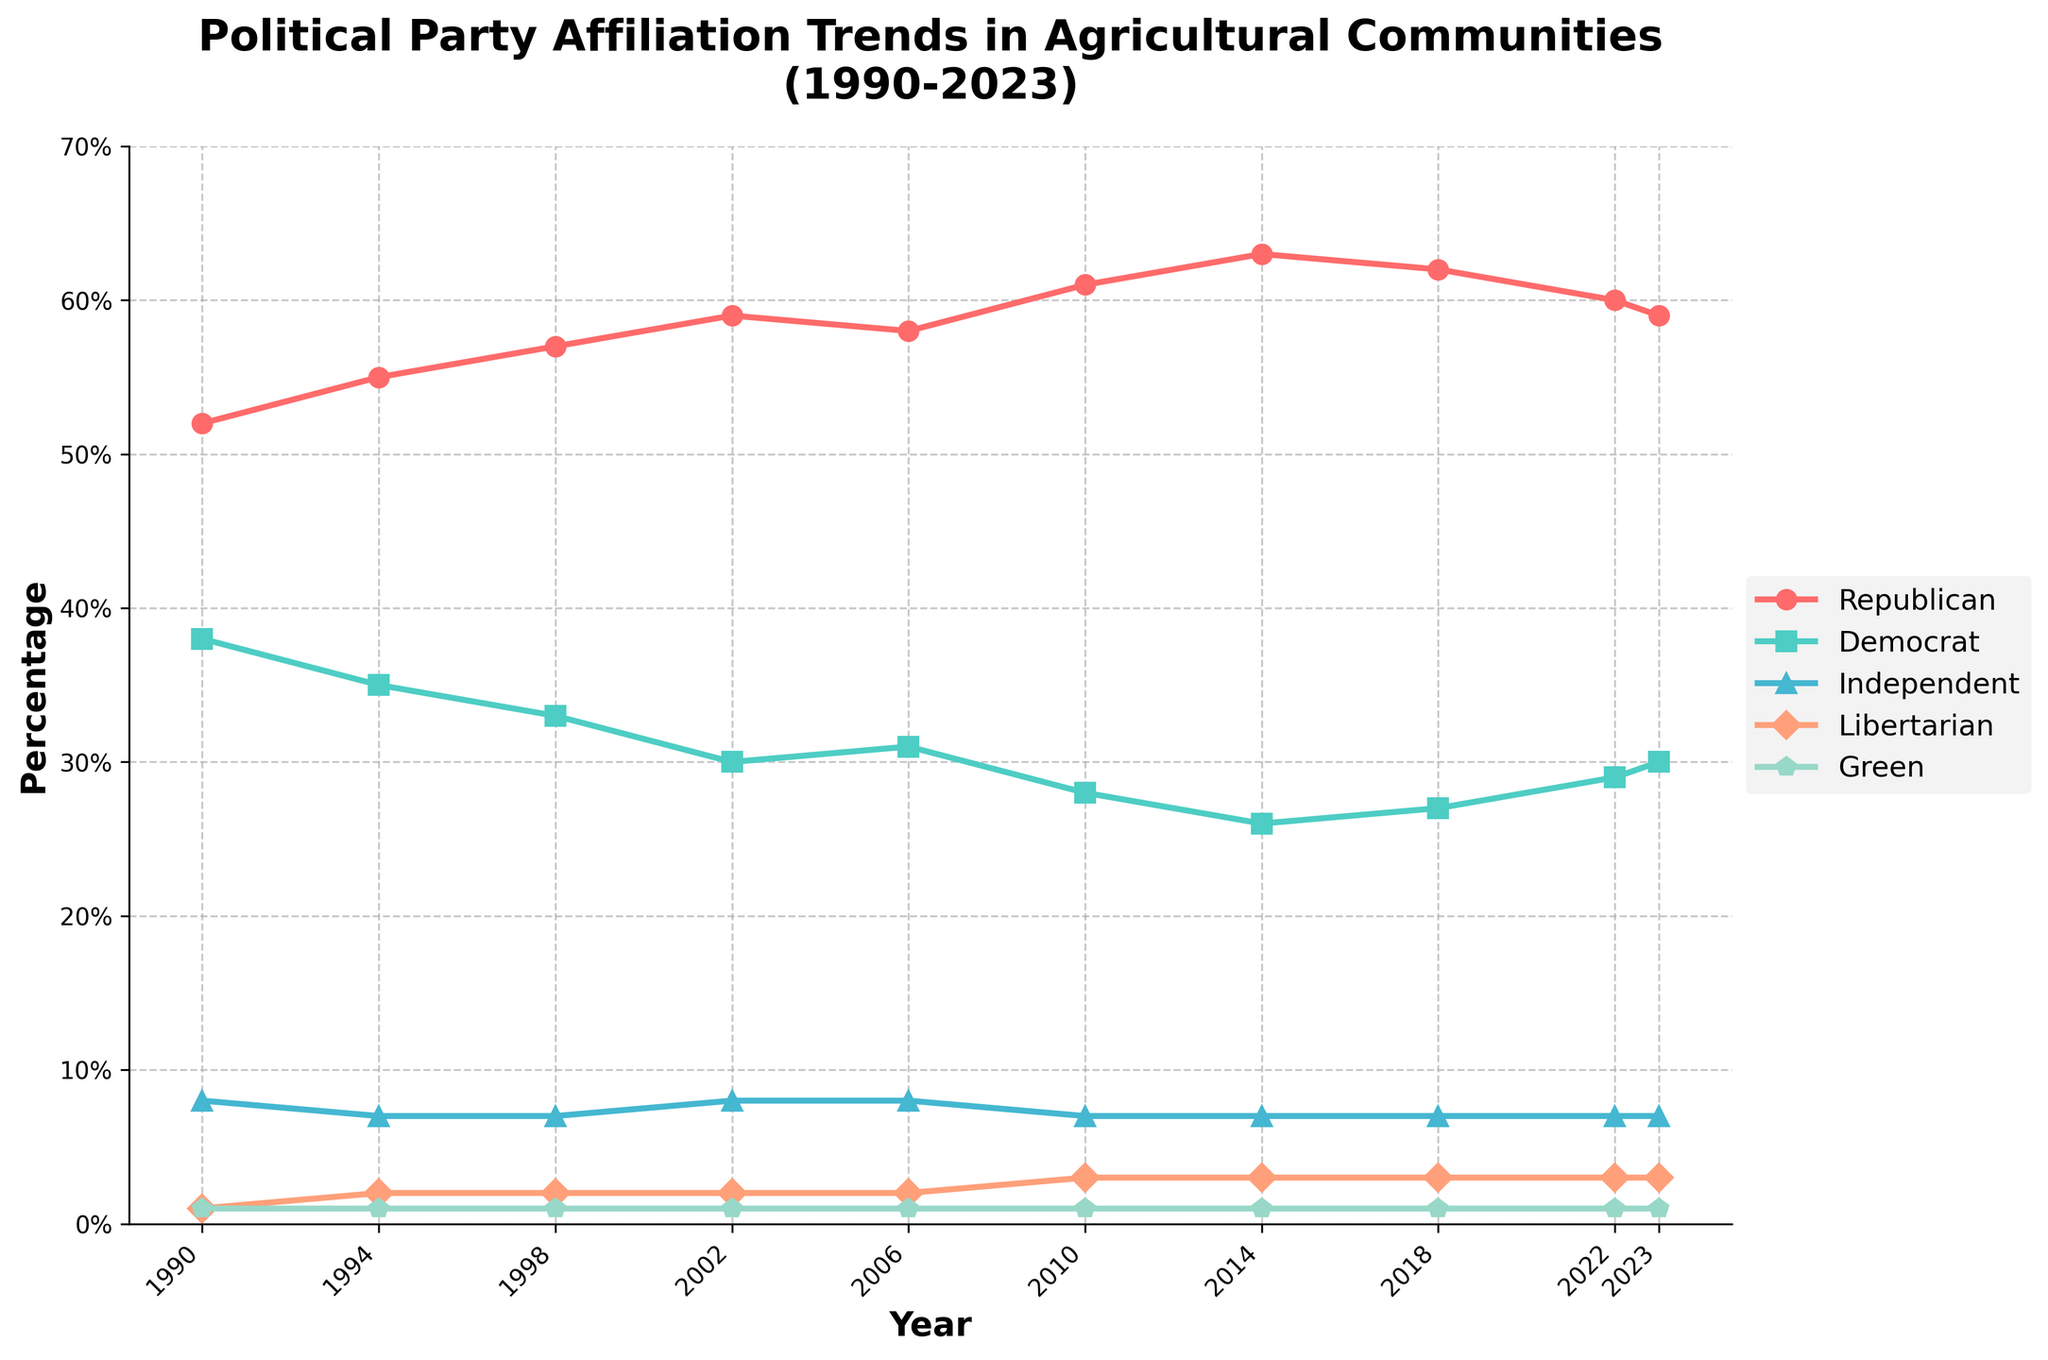What was the trend of Republican affiliation from 1990 to 2023? From the plot, we observe that Republican affiliation started at 52% in 1990, peaked at 63% in 2014, and then slightly dropped to 59% in 2023.
Answer: The trend shows a general increase followed by a slight decrease How did Democratic affiliation change from 2010 to 2014? From the figure, Democratic affiliation decreased from 28% in 2010 to 26% in 2014.
Answer: It decreased by 2% Which political groups remained constant in their percentage from 1990 to 2023? The Independent, Libertarian, and Green groups all show constant values of 7%, 3%, and 1%, respectively, over the years presented.
Answer: Independent, Libertarian, and Green parties Compare the percentage of Republican affiliation in 1990 and 2023. What is the difference? In 1990, the Republican affiliation was 52%, and in 2023, it was 59%. The difference is 59% - 52% = 7%.
Answer: 7% What is the average percentage of Democratic affiliation across all years shown? Summing the percentages of Democratic affiliation across the years (38 + 35 + 33 + 30 + 31 + 28 + 26 + 27 + 29 + 30) gives 307. Dividing by 10 (the number of years) gives an average of 30.7%.
Answer: 30.7% When did Republican affiliation reach its peak, and what was the percentage? Republican affiliation peaked in 2014 and the percentage was 63%.
Answer: 2014, 63% Compare the trends of Republican and Democratic affiliations from 1990 to 2002. The Republican affiliation consistently increased from 52% to 59%, while Democratic affiliation consistently decreased from 38% to 30%.
Answer: Republican increased, Democrat decreased What was the difference in Democratic affiliation between 1990 and 2023? In 1990 Democratic affiliation was 38%, and in 2023 it was 30%. The difference is 38% - 30% = 8%.
Answer: 8% Which political affiliation showed the least variation over the years? The Green affiliation remained constant at 1% throughout the years, showing the least variation.
Answer: Green party How did the percentage of Libertarian affiliation compare in 2002 and 2010? In 2002, Libertarian affiliation was 2%, and in 2010 it was 3%. The percentage increased by 1%.
Answer: Increased by 1% 